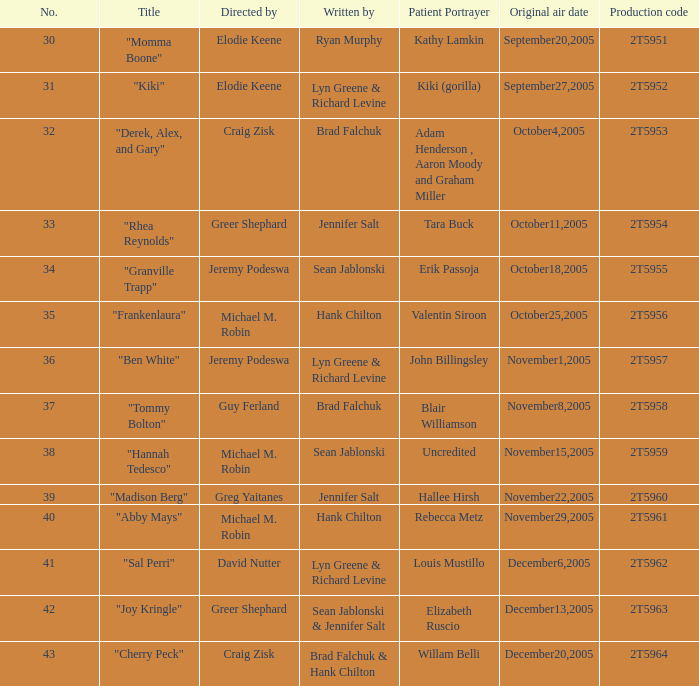What is the total number of patient portayers for the episode directed by Craig Zisk and written by Brad Falchuk? 1.0. 